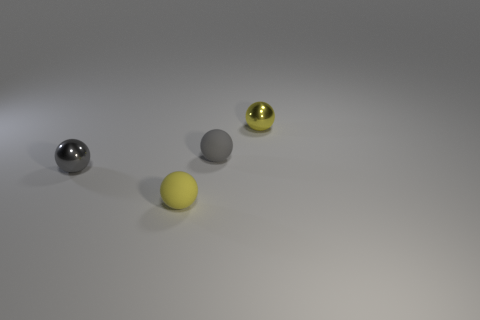What shape is the small thing that is behind the yellow rubber sphere and to the left of the small gray rubber sphere?
Your answer should be compact. Sphere. Is the number of small yellow matte cubes less than the number of yellow rubber things?
Keep it short and to the point. Yes. The gray object that is behind the shiny ball to the left of the yellow metal thing that is behind the gray metallic sphere is made of what material?
Give a very brief answer. Rubber. Is the material of the ball that is in front of the small gray metallic ball the same as the small yellow sphere behind the gray metal ball?
Give a very brief answer. No. There is a yellow sphere that is the same size as the yellow metallic thing; what is it made of?
Make the answer very short. Rubber. There is a gray object that is on the right side of the yellow sphere that is on the left side of the gray rubber thing; what number of tiny yellow balls are in front of it?
Your response must be concise. 1. Does the small thing on the left side of the yellow matte thing have the same color as the tiny rubber thing that is behind the small yellow rubber thing?
Your response must be concise. Yes. There is a tiny ball that is on the right side of the tiny gray metallic ball and left of the small gray rubber ball; what color is it?
Give a very brief answer. Yellow. How many gray things have the same size as the yellow metallic thing?
Offer a very short reply. 2. What is the shape of the tiny metallic thing behind the tiny sphere that is on the left side of the tiny yellow matte thing?
Offer a very short reply. Sphere. 